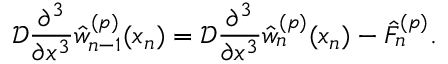<formula> <loc_0><loc_0><loc_500><loc_500>\mathcal { D } \frac { \partial ^ { 3 } } { \partial x ^ { 3 } } \hat { w } _ { n - 1 } ^ { ( p ) } ( x _ { n } ) = \mathcal { D } \frac { \partial ^ { 3 } } { \partial x ^ { 3 } } \hat { w } _ { n } ^ { ( p ) } ( x _ { n } ) - \hat { F } _ { n } ^ { ( p ) } .</formula> 